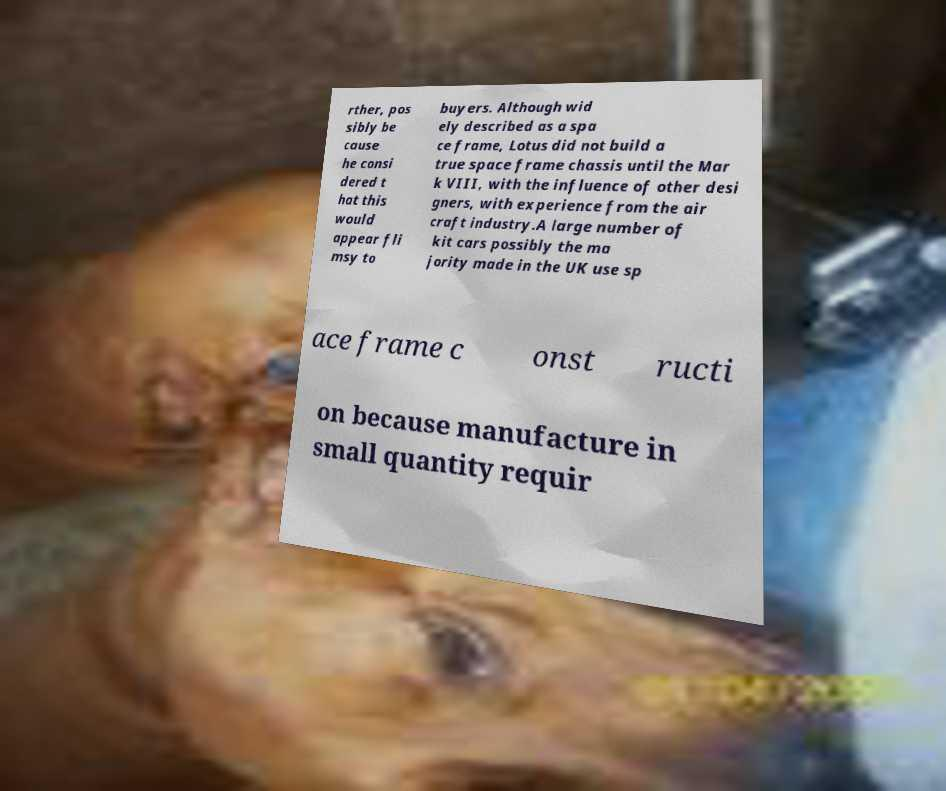Can you read and provide the text displayed in the image?This photo seems to have some interesting text. Can you extract and type it out for me? rther, pos sibly be cause he consi dered t hat this would appear fli msy to buyers. Although wid ely described as a spa ce frame, Lotus did not build a true space frame chassis until the Mar k VIII, with the influence of other desi gners, with experience from the air craft industry.A large number of kit cars possibly the ma jority made in the UK use sp ace frame c onst ructi on because manufacture in small quantity requir 